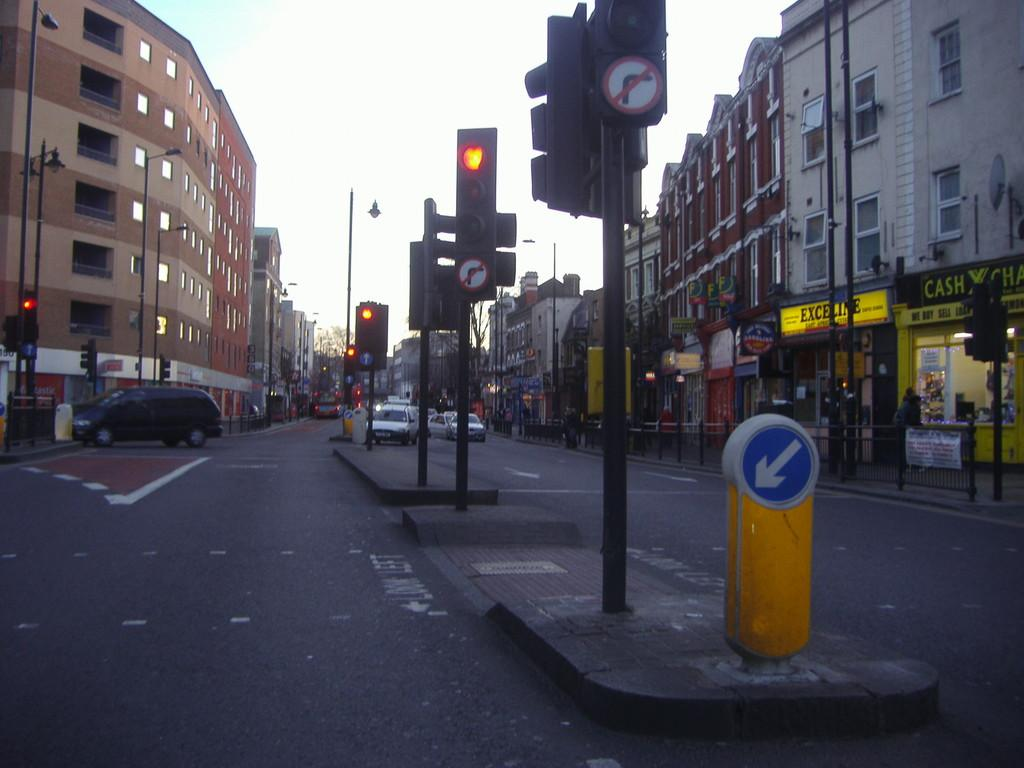Provide a one-sentence caption for the provided image. A road where there are shopping stores on the right including Cash X Change/. 